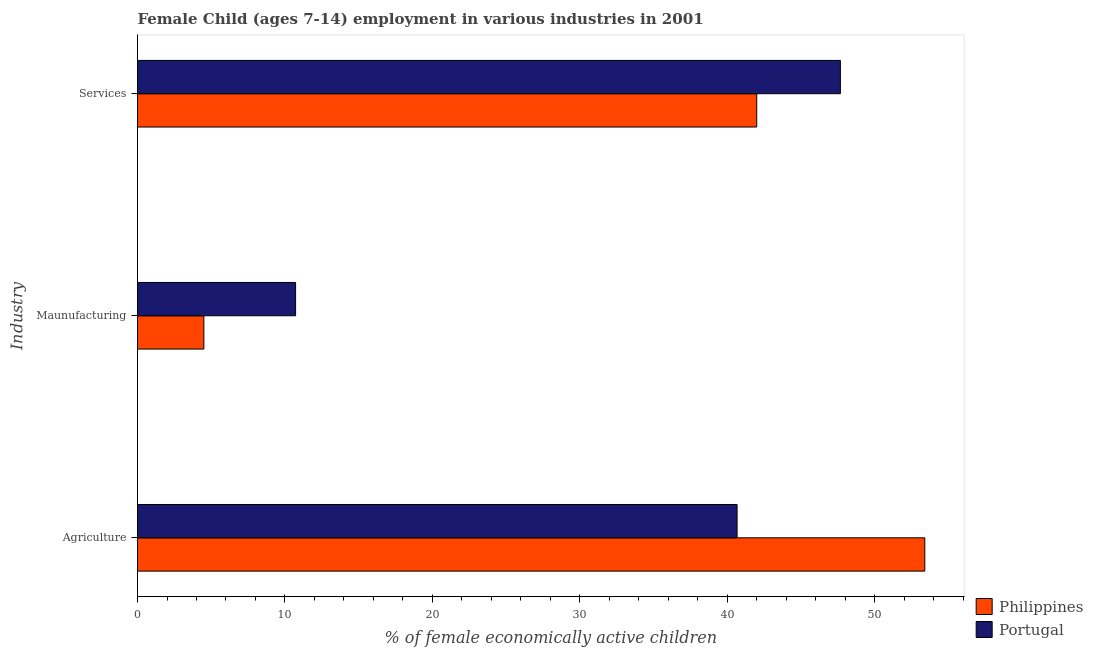How many different coloured bars are there?
Offer a very short reply. 2. How many bars are there on the 2nd tick from the bottom?
Ensure brevity in your answer.  2. What is the label of the 1st group of bars from the top?
Provide a short and direct response. Services. What is the percentage of economically active children in agriculture in Portugal?
Ensure brevity in your answer.  40.67. Across all countries, what is the maximum percentage of economically active children in agriculture?
Your answer should be compact. 53.4. Across all countries, what is the minimum percentage of economically active children in agriculture?
Provide a succinct answer. 40.67. In which country was the percentage of economically active children in manufacturing minimum?
Ensure brevity in your answer.  Philippines. What is the total percentage of economically active children in services in the graph?
Ensure brevity in your answer.  89.67. What is the difference between the percentage of economically active children in manufacturing in Philippines and that in Portugal?
Your answer should be very brief. -6.22. What is the difference between the percentage of economically active children in manufacturing in Portugal and the percentage of economically active children in agriculture in Philippines?
Offer a terse response. -42.68. What is the average percentage of economically active children in agriculture per country?
Your response must be concise. 47.03. What is the difference between the percentage of economically active children in agriculture and percentage of economically active children in manufacturing in Portugal?
Offer a very short reply. 29.94. In how many countries, is the percentage of economically active children in agriculture greater than 16 %?
Keep it short and to the point. 2. What is the ratio of the percentage of economically active children in services in Philippines to that in Portugal?
Your answer should be compact. 0.88. Is the percentage of economically active children in agriculture in Portugal less than that in Philippines?
Your response must be concise. Yes. What is the difference between the highest and the second highest percentage of economically active children in services?
Your answer should be compact. 5.67. What is the difference between the highest and the lowest percentage of economically active children in services?
Offer a terse response. 5.67. In how many countries, is the percentage of economically active children in manufacturing greater than the average percentage of economically active children in manufacturing taken over all countries?
Ensure brevity in your answer.  1. Are the values on the major ticks of X-axis written in scientific E-notation?
Offer a very short reply. No. Does the graph contain grids?
Offer a very short reply. No. How many legend labels are there?
Your answer should be very brief. 2. How are the legend labels stacked?
Offer a very short reply. Vertical. What is the title of the graph?
Offer a very short reply. Female Child (ages 7-14) employment in various industries in 2001. What is the label or title of the X-axis?
Give a very brief answer. % of female economically active children. What is the label or title of the Y-axis?
Keep it short and to the point. Industry. What is the % of female economically active children in Philippines in Agriculture?
Ensure brevity in your answer.  53.4. What is the % of female economically active children in Portugal in Agriculture?
Offer a very short reply. 40.67. What is the % of female economically active children in Portugal in Maunufacturing?
Provide a short and direct response. 10.72. What is the % of female economically active children of Portugal in Services?
Offer a very short reply. 47.67. Across all Industry, what is the maximum % of female economically active children in Philippines?
Give a very brief answer. 53.4. Across all Industry, what is the maximum % of female economically active children of Portugal?
Ensure brevity in your answer.  47.67. Across all Industry, what is the minimum % of female economically active children of Portugal?
Provide a succinct answer. 10.72. What is the total % of female economically active children in Philippines in the graph?
Offer a terse response. 99.9. What is the total % of female economically active children in Portugal in the graph?
Provide a short and direct response. 99.06. What is the difference between the % of female economically active children of Philippines in Agriculture and that in Maunufacturing?
Make the answer very short. 48.9. What is the difference between the % of female economically active children in Portugal in Agriculture and that in Maunufacturing?
Keep it short and to the point. 29.94. What is the difference between the % of female economically active children in Philippines in Agriculture and that in Services?
Provide a short and direct response. 11.4. What is the difference between the % of female economically active children of Portugal in Agriculture and that in Services?
Keep it short and to the point. -7.01. What is the difference between the % of female economically active children in Philippines in Maunufacturing and that in Services?
Ensure brevity in your answer.  -37.5. What is the difference between the % of female economically active children of Portugal in Maunufacturing and that in Services?
Provide a succinct answer. -36.95. What is the difference between the % of female economically active children in Philippines in Agriculture and the % of female economically active children in Portugal in Maunufacturing?
Provide a succinct answer. 42.68. What is the difference between the % of female economically active children of Philippines in Agriculture and the % of female economically active children of Portugal in Services?
Ensure brevity in your answer.  5.73. What is the difference between the % of female economically active children of Philippines in Maunufacturing and the % of female economically active children of Portugal in Services?
Your answer should be compact. -43.17. What is the average % of female economically active children of Philippines per Industry?
Your response must be concise. 33.3. What is the average % of female economically active children of Portugal per Industry?
Ensure brevity in your answer.  33.02. What is the difference between the % of female economically active children of Philippines and % of female economically active children of Portugal in Agriculture?
Your answer should be very brief. 12.73. What is the difference between the % of female economically active children of Philippines and % of female economically active children of Portugal in Maunufacturing?
Provide a short and direct response. -6.22. What is the difference between the % of female economically active children in Philippines and % of female economically active children in Portugal in Services?
Offer a terse response. -5.67. What is the ratio of the % of female economically active children of Philippines in Agriculture to that in Maunufacturing?
Your answer should be compact. 11.87. What is the ratio of the % of female economically active children in Portugal in Agriculture to that in Maunufacturing?
Provide a short and direct response. 3.79. What is the ratio of the % of female economically active children in Philippines in Agriculture to that in Services?
Your answer should be very brief. 1.27. What is the ratio of the % of female economically active children of Portugal in Agriculture to that in Services?
Offer a very short reply. 0.85. What is the ratio of the % of female economically active children in Philippines in Maunufacturing to that in Services?
Ensure brevity in your answer.  0.11. What is the ratio of the % of female economically active children of Portugal in Maunufacturing to that in Services?
Make the answer very short. 0.22. What is the difference between the highest and the second highest % of female economically active children in Philippines?
Make the answer very short. 11.4. What is the difference between the highest and the second highest % of female economically active children in Portugal?
Give a very brief answer. 7.01. What is the difference between the highest and the lowest % of female economically active children of Philippines?
Keep it short and to the point. 48.9. What is the difference between the highest and the lowest % of female economically active children in Portugal?
Your answer should be very brief. 36.95. 